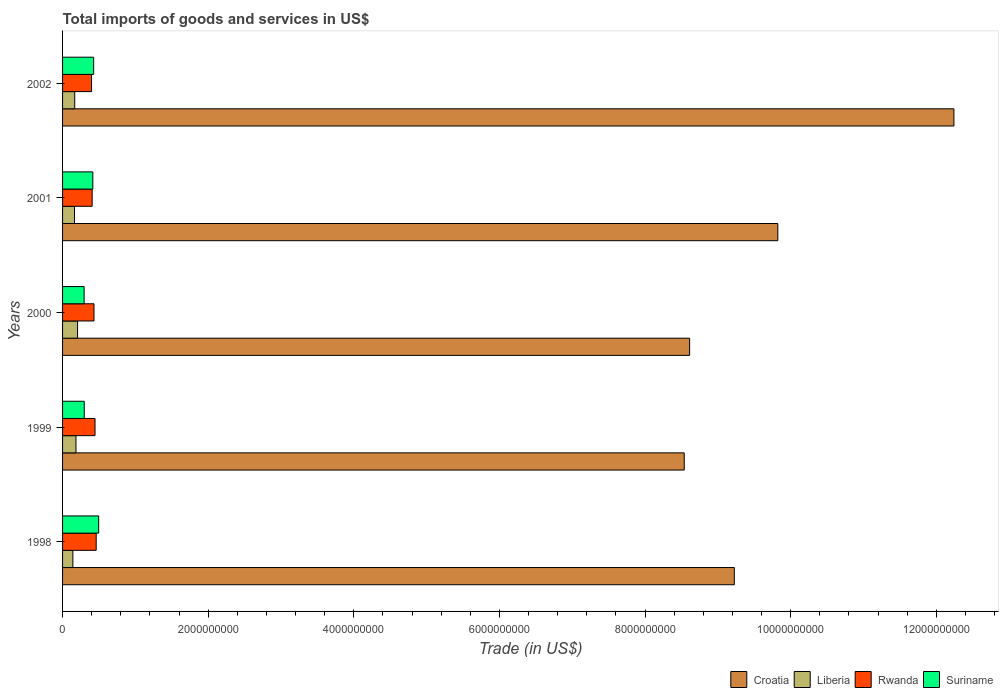How many different coloured bars are there?
Offer a very short reply. 4. How many groups of bars are there?
Keep it short and to the point. 5. Are the number of bars per tick equal to the number of legend labels?
Keep it short and to the point. Yes. How many bars are there on the 5th tick from the bottom?
Your response must be concise. 4. What is the total imports of goods and services in Croatia in 1998?
Ensure brevity in your answer.  9.23e+09. Across all years, what is the maximum total imports of goods and services in Liberia?
Make the answer very short. 2.06e+08. Across all years, what is the minimum total imports of goods and services in Rwanda?
Give a very brief answer. 3.98e+08. In which year was the total imports of goods and services in Suriname minimum?
Make the answer very short. 2000. What is the total total imports of goods and services in Rwanda in the graph?
Ensure brevity in your answer.  2.14e+09. What is the difference between the total imports of goods and services in Liberia in 1998 and that in 2001?
Make the answer very short. -2.22e+07. What is the difference between the total imports of goods and services in Liberia in 2001 and the total imports of goods and services in Rwanda in 2002?
Provide a succinct answer. -2.34e+08. What is the average total imports of goods and services in Rwanda per year?
Your answer should be very brief. 4.29e+08. In the year 1998, what is the difference between the total imports of goods and services in Rwanda and total imports of goods and services in Suriname?
Offer a terse response. -3.43e+07. In how many years, is the total imports of goods and services in Rwanda greater than 6000000000 US$?
Your answer should be very brief. 0. What is the ratio of the total imports of goods and services in Croatia in 1998 to that in 1999?
Give a very brief answer. 1.08. Is the total imports of goods and services in Liberia in 2000 less than that in 2002?
Offer a very short reply. No. Is the difference between the total imports of goods and services in Rwanda in 1998 and 1999 greater than the difference between the total imports of goods and services in Suriname in 1998 and 1999?
Offer a very short reply. No. What is the difference between the highest and the second highest total imports of goods and services in Rwanda?
Your response must be concise. 1.59e+07. What is the difference between the highest and the lowest total imports of goods and services in Liberia?
Offer a terse response. 6.45e+07. Is it the case that in every year, the sum of the total imports of goods and services in Croatia and total imports of goods and services in Suriname is greater than the sum of total imports of goods and services in Liberia and total imports of goods and services in Rwanda?
Make the answer very short. Yes. What does the 2nd bar from the top in 2001 represents?
Provide a short and direct response. Rwanda. What does the 1st bar from the bottom in 1998 represents?
Offer a very short reply. Croatia. What is the difference between two consecutive major ticks on the X-axis?
Provide a succinct answer. 2.00e+09. Does the graph contain any zero values?
Provide a succinct answer. No. Where does the legend appear in the graph?
Provide a succinct answer. Bottom right. What is the title of the graph?
Keep it short and to the point. Total imports of goods and services in US$. What is the label or title of the X-axis?
Offer a very short reply. Trade (in US$). What is the Trade (in US$) in Croatia in 1998?
Your answer should be compact. 9.23e+09. What is the Trade (in US$) of Liberia in 1998?
Offer a terse response. 1.42e+08. What is the Trade (in US$) of Rwanda in 1998?
Offer a very short reply. 4.62e+08. What is the Trade (in US$) of Suriname in 1998?
Your answer should be compact. 4.96e+08. What is the Trade (in US$) in Croatia in 1999?
Keep it short and to the point. 8.54e+09. What is the Trade (in US$) in Liberia in 1999?
Keep it short and to the point. 1.84e+08. What is the Trade (in US$) of Rwanda in 1999?
Ensure brevity in your answer.  4.46e+08. What is the Trade (in US$) in Suriname in 1999?
Keep it short and to the point. 2.98e+08. What is the Trade (in US$) in Croatia in 2000?
Make the answer very short. 8.61e+09. What is the Trade (in US$) in Liberia in 2000?
Offer a terse response. 2.06e+08. What is the Trade (in US$) of Rwanda in 2000?
Offer a terse response. 4.32e+08. What is the Trade (in US$) of Suriname in 2000?
Your answer should be very brief. 2.96e+08. What is the Trade (in US$) of Croatia in 2001?
Offer a very short reply. 9.82e+09. What is the Trade (in US$) in Liberia in 2001?
Provide a short and direct response. 1.64e+08. What is the Trade (in US$) of Rwanda in 2001?
Your answer should be very brief. 4.07e+08. What is the Trade (in US$) of Suriname in 2001?
Provide a short and direct response. 4.16e+08. What is the Trade (in US$) in Croatia in 2002?
Offer a terse response. 1.22e+1. What is the Trade (in US$) in Liberia in 2002?
Your answer should be compact. 1.67e+08. What is the Trade (in US$) in Rwanda in 2002?
Make the answer very short. 3.98e+08. What is the Trade (in US$) in Suriname in 2002?
Ensure brevity in your answer.  4.27e+08. Across all years, what is the maximum Trade (in US$) in Croatia?
Your response must be concise. 1.22e+1. Across all years, what is the maximum Trade (in US$) in Liberia?
Provide a short and direct response. 2.06e+08. Across all years, what is the maximum Trade (in US$) in Rwanda?
Make the answer very short. 4.62e+08. Across all years, what is the maximum Trade (in US$) of Suriname?
Your response must be concise. 4.96e+08. Across all years, what is the minimum Trade (in US$) of Croatia?
Your answer should be compact. 8.54e+09. Across all years, what is the minimum Trade (in US$) in Liberia?
Your answer should be very brief. 1.42e+08. Across all years, what is the minimum Trade (in US$) of Rwanda?
Your response must be concise. 3.98e+08. Across all years, what is the minimum Trade (in US$) of Suriname?
Offer a terse response. 2.96e+08. What is the total Trade (in US$) of Croatia in the graph?
Keep it short and to the point. 4.84e+1. What is the total Trade (in US$) in Liberia in the graph?
Provide a short and direct response. 8.62e+08. What is the total Trade (in US$) in Rwanda in the graph?
Ensure brevity in your answer.  2.14e+09. What is the total Trade (in US$) of Suriname in the graph?
Offer a very short reply. 1.93e+09. What is the difference between the Trade (in US$) of Croatia in 1998 and that in 1999?
Ensure brevity in your answer.  6.88e+08. What is the difference between the Trade (in US$) of Liberia in 1998 and that in 1999?
Provide a short and direct response. -4.26e+07. What is the difference between the Trade (in US$) of Rwanda in 1998 and that in 1999?
Offer a very short reply. 1.59e+07. What is the difference between the Trade (in US$) in Suriname in 1998 and that in 1999?
Your answer should be compact. 1.98e+08. What is the difference between the Trade (in US$) of Croatia in 1998 and that in 2000?
Your response must be concise. 6.14e+08. What is the difference between the Trade (in US$) in Liberia in 1998 and that in 2000?
Offer a very short reply. -6.45e+07. What is the difference between the Trade (in US$) in Rwanda in 1998 and that in 2000?
Keep it short and to the point. 3.01e+07. What is the difference between the Trade (in US$) in Suriname in 1998 and that in 2000?
Ensure brevity in your answer.  2.00e+08. What is the difference between the Trade (in US$) of Croatia in 1998 and that in 2001?
Ensure brevity in your answer.  -5.98e+08. What is the difference between the Trade (in US$) of Liberia in 1998 and that in 2001?
Your answer should be compact. -2.22e+07. What is the difference between the Trade (in US$) of Rwanda in 1998 and that in 2001?
Your response must be concise. 5.52e+07. What is the difference between the Trade (in US$) in Suriname in 1998 and that in 2001?
Ensure brevity in your answer.  8.05e+07. What is the difference between the Trade (in US$) of Croatia in 1998 and that in 2002?
Your response must be concise. -3.02e+09. What is the difference between the Trade (in US$) of Liberia in 1998 and that in 2002?
Provide a succinct answer. -2.56e+07. What is the difference between the Trade (in US$) in Rwanda in 1998 and that in 2002?
Your response must be concise. 6.39e+07. What is the difference between the Trade (in US$) of Suriname in 1998 and that in 2002?
Offer a terse response. 6.91e+07. What is the difference between the Trade (in US$) of Croatia in 1999 and that in 2000?
Ensure brevity in your answer.  -7.35e+07. What is the difference between the Trade (in US$) in Liberia in 1999 and that in 2000?
Provide a succinct answer. -2.19e+07. What is the difference between the Trade (in US$) in Rwanda in 1999 and that in 2000?
Your answer should be very brief. 1.42e+07. What is the difference between the Trade (in US$) of Suriname in 1999 and that in 2000?
Your response must be concise. 1.62e+06. What is the difference between the Trade (in US$) in Croatia in 1999 and that in 2001?
Offer a terse response. -1.29e+09. What is the difference between the Trade (in US$) in Liberia in 1999 and that in 2001?
Make the answer very short. 2.04e+07. What is the difference between the Trade (in US$) in Rwanda in 1999 and that in 2001?
Keep it short and to the point. 3.92e+07. What is the difference between the Trade (in US$) in Suriname in 1999 and that in 2001?
Make the answer very short. -1.18e+08. What is the difference between the Trade (in US$) in Croatia in 1999 and that in 2002?
Provide a succinct answer. -3.70e+09. What is the difference between the Trade (in US$) in Liberia in 1999 and that in 2002?
Provide a short and direct response. 1.70e+07. What is the difference between the Trade (in US$) of Rwanda in 1999 and that in 2002?
Offer a terse response. 4.80e+07. What is the difference between the Trade (in US$) in Suriname in 1999 and that in 2002?
Ensure brevity in your answer.  -1.29e+08. What is the difference between the Trade (in US$) in Croatia in 2000 and that in 2001?
Give a very brief answer. -1.21e+09. What is the difference between the Trade (in US$) in Liberia in 2000 and that in 2001?
Offer a terse response. 4.23e+07. What is the difference between the Trade (in US$) in Rwanda in 2000 and that in 2001?
Your response must be concise. 2.51e+07. What is the difference between the Trade (in US$) of Suriname in 2000 and that in 2001?
Give a very brief answer. -1.19e+08. What is the difference between the Trade (in US$) in Croatia in 2000 and that in 2002?
Provide a short and direct response. -3.63e+09. What is the difference between the Trade (in US$) of Liberia in 2000 and that in 2002?
Your answer should be very brief. 3.89e+07. What is the difference between the Trade (in US$) of Rwanda in 2000 and that in 2002?
Offer a terse response. 3.38e+07. What is the difference between the Trade (in US$) of Suriname in 2000 and that in 2002?
Your answer should be compact. -1.31e+08. What is the difference between the Trade (in US$) in Croatia in 2001 and that in 2002?
Give a very brief answer. -2.42e+09. What is the difference between the Trade (in US$) of Liberia in 2001 and that in 2002?
Keep it short and to the point. -3.44e+06. What is the difference between the Trade (in US$) of Rwanda in 2001 and that in 2002?
Make the answer very short. 8.75e+06. What is the difference between the Trade (in US$) in Suriname in 2001 and that in 2002?
Ensure brevity in your answer.  -1.14e+07. What is the difference between the Trade (in US$) in Croatia in 1998 and the Trade (in US$) in Liberia in 1999?
Keep it short and to the point. 9.04e+09. What is the difference between the Trade (in US$) in Croatia in 1998 and the Trade (in US$) in Rwanda in 1999?
Keep it short and to the point. 8.78e+09. What is the difference between the Trade (in US$) in Croatia in 1998 and the Trade (in US$) in Suriname in 1999?
Make the answer very short. 8.93e+09. What is the difference between the Trade (in US$) of Liberia in 1998 and the Trade (in US$) of Rwanda in 1999?
Give a very brief answer. -3.04e+08. What is the difference between the Trade (in US$) of Liberia in 1998 and the Trade (in US$) of Suriname in 1999?
Offer a very short reply. -1.56e+08. What is the difference between the Trade (in US$) of Rwanda in 1998 and the Trade (in US$) of Suriname in 1999?
Offer a very short reply. 1.64e+08. What is the difference between the Trade (in US$) in Croatia in 1998 and the Trade (in US$) in Liberia in 2000?
Your response must be concise. 9.02e+09. What is the difference between the Trade (in US$) of Croatia in 1998 and the Trade (in US$) of Rwanda in 2000?
Give a very brief answer. 8.79e+09. What is the difference between the Trade (in US$) of Croatia in 1998 and the Trade (in US$) of Suriname in 2000?
Provide a short and direct response. 8.93e+09. What is the difference between the Trade (in US$) in Liberia in 1998 and the Trade (in US$) in Rwanda in 2000?
Give a very brief answer. -2.90e+08. What is the difference between the Trade (in US$) of Liberia in 1998 and the Trade (in US$) of Suriname in 2000?
Your response must be concise. -1.55e+08. What is the difference between the Trade (in US$) of Rwanda in 1998 and the Trade (in US$) of Suriname in 2000?
Ensure brevity in your answer.  1.66e+08. What is the difference between the Trade (in US$) in Croatia in 1998 and the Trade (in US$) in Liberia in 2001?
Offer a terse response. 9.06e+09. What is the difference between the Trade (in US$) in Croatia in 1998 and the Trade (in US$) in Rwanda in 2001?
Make the answer very short. 8.82e+09. What is the difference between the Trade (in US$) in Croatia in 1998 and the Trade (in US$) in Suriname in 2001?
Provide a succinct answer. 8.81e+09. What is the difference between the Trade (in US$) of Liberia in 1998 and the Trade (in US$) of Rwanda in 2001?
Ensure brevity in your answer.  -2.65e+08. What is the difference between the Trade (in US$) in Liberia in 1998 and the Trade (in US$) in Suriname in 2001?
Ensure brevity in your answer.  -2.74e+08. What is the difference between the Trade (in US$) of Rwanda in 1998 and the Trade (in US$) of Suriname in 2001?
Offer a terse response. 4.62e+07. What is the difference between the Trade (in US$) in Croatia in 1998 and the Trade (in US$) in Liberia in 2002?
Ensure brevity in your answer.  9.06e+09. What is the difference between the Trade (in US$) in Croatia in 1998 and the Trade (in US$) in Rwanda in 2002?
Make the answer very short. 8.83e+09. What is the difference between the Trade (in US$) of Croatia in 1998 and the Trade (in US$) of Suriname in 2002?
Give a very brief answer. 8.80e+09. What is the difference between the Trade (in US$) in Liberia in 1998 and the Trade (in US$) in Rwanda in 2002?
Offer a very short reply. -2.56e+08. What is the difference between the Trade (in US$) of Liberia in 1998 and the Trade (in US$) of Suriname in 2002?
Your answer should be compact. -2.85e+08. What is the difference between the Trade (in US$) of Rwanda in 1998 and the Trade (in US$) of Suriname in 2002?
Give a very brief answer. 3.48e+07. What is the difference between the Trade (in US$) in Croatia in 1999 and the Trade (in US$) in Liberia in 2000?
Give a very brief answer. 8.33e+09. What is the difference between the Trade (in US$) of Croatia in 1999 and the Trade (in US$) of Rwanda in 2000?
Give a very brief answer. 8.11e+09. What is the difference between the Trade (in US$) in Croatia in 1999 and the Trade (in US$) in Suriname in 2000?
Give a very brief answer. 8.24e+09. What is the difference between the Trade (in US$) of Liberia in 1999 and the Trade (in US$) of Rwanda in 2000?
Offer a terse response. -2.48e+08. What is the difference between the Trade (in US$) of Liberia in 1999 and the Trade (in US$) of Suriname in 2000?
Keep it short and to the point. -1.12e+08. What is the difference between the Trade (in US$) of Rwanda in 1999 and the Trade (in US$) of Suriname in 2000?
Provide a short and direct response. 1.50e+08. What is the difference between the Trade (in US$) of Croatia in 1999 and the Trade (in US$) of Liberia in 2001?
Offer a terse response. 8.37e+09. What is the difference between the Trade (in US$) of Croatia in 1999 and the Trade (in US$) of Rwanda in 2001?
Offer a very short reply. 8.13e+09. What is the difference between the Trade (in US$) of Croatia in 1999 and the Trade (in US$) of Suriname in 2001?
Your answer should be compact. 8.12e+09. What is the difference between the Trade (in US$) of Liberia in 1999 and the Trade (in US$) of Rwanda in 2001?
Your answer should be very brief. -2.22e+08. What is the difference between the Trade (in US$) in Liberia in 1999 and the Trade (in US$) in Suriname in 2001?
Your answer should be very brief. -2.31e+08. What is the difference between the Trade (in US$) in Rwanda in 1999 and the Trade (in US$) in Suriname in 2001?
Provide a succinct answer. 3.03e+07. What is the difference between the Trade (in US$) in Croatia in 1999 and the Trade (in US$) in Liberia in 2002?
Ensure brevity in your answer.  8.37e+09. What is the difference between the Trade (in US$) in Croatia in 1999 and the Trade (in US$) in Rwanda in 2002?
Your response must be concise. 8.14e+09. What is the difference between the Trade (in US$) in Croatia in 1999 and the Trade (in US$) in Suriname in 2002?
Give a very brief answer. 8.11e+09. What is the difference between the Trade (in US$) of Liberia in 1999 and the Trade (in US$) of Rwanda in 2002?
Give a very brief answer. -2.14e+08. What is the difference between the Trade (in US$) in Liberia in 1999 and the Trade (in US$) in Suriname in 2002?
Your response must be concise. -2.43e+08. What is the difference between the Trade (in US$) in Rwanda in 1999 and the Trade (in US$) in Suriname in 2002?
Provide a succinct answer. 1.89e+07. What is the difference between the Trade (in US$) in Croatia in 2000 and the Trade (in US$) in Liberia in 2001?
Make the answer very short. 8.45e+09. What is the difference between the Trade (in US$) in Croatia in 2000 and the Trade (in US$) in Rwanda in 2001?
Your response must be concise. 8.21e+09. What is the difference between the Trade (in US$) of Croatia in 2000 and the Trade (in US$) of Suriname in 2001?
Your answer should be very brief. 8.20e+09. What is the difference between the Trade (in US$) of Liberia in 2000 and the Trade (in US$) of Rwanda in 2001?
Give a very brief answer. -2.01e+08. What is the difference between the Trade (in US$) in Liberia in 2000 and the Trade (in US$) in Suriname in 2001?
Your response must be concise. -2.10e+08. What is the difference between the Trade (in US$) in Rwanda in 2000 and the Trade (in US$) in Suriname in 2001?
Your answer should be very brief. 1.61e+07. What is the difference between the Trade (in US$) in Croatia in 2000 and the Trade (in US$) in Liberia in 2002?
Provide a succinct answer. 8.45e+09. What is the difference between the Trade (in US$) in Croatia in 2000 and the Trade (in US$) in Rwanda in 2002?
Offer a very short reply. 8.21e+09. What is the difference between the Trade (in US$) of Croatia in 2000 and the Trade (in US$) of Suriname in 2002?
Give a very brief answer. 8.19e+09. What is the difference between the Trade (in US$) of Liberia in 2000 and the Trade (in US$) of Rwanda in 2002?
Keep it short and to the point. -1.92e+08. What is the difference between the Trade (in US$) of Liberia in 2000 and the Trade (in US$) of Suriname in 2002?
Your response must be concise. -2.21e+08. What is the difference between the Trade (in US$) in Rwanda in 2000 and the Trade (in US$) in Suriname in 2002?
Make the answer very short. 4.70e+06. What is the difference between the Trade (in US$) in Croatia in 2001 and the Trade (in US$) in Liberia in 2002?
Your answer should be very brief. 9.66e+09. What is the difference between the Trade (in US$) in Croatia in 2001 and the Trade (in US$) in Rwanda in 2002?
Keep it short and to the point. 9.43e+09. What is the difference between the Trade (in US$) in Croatia in 2001 and the Trade (in US$) in Suriname in 2002?
Give a very brief answer. 9.40e+09. What is the difference between the Trade (in US$) of Liberia in 2001 and the Trade (in US$) of Rwanda in 2002?
Provide a short and direct response. -2.34e+08. What is the difference between the Trade (in US$) of Liberia in 2001 and the Trade (in US$) of Suriname in 2002?
Ensure brevity in your answer.  -2.63e+08. What is the difference between the Trade (in US$) in Rwanda in 2001 and the Trade (in US$) in Suriname in 2002?
Your response must be concise. -2.04e+07. What is the average Trade (in US$) in Croatia per year?
Provide a succinct answer. 9.69e+09. What is the average Trade (in US$) in Liberia per year?
Offer a terse response. 1.72e+08. What is the average Trade (in US$) of Rwanda per year?
Give a very brief answer. 4.29e+08. What is the average Trade (in US$) of Suriname per year?
Offer a very short reply. 3.86e+08. In the year 1998, what is the difference between the Trade (in US$) of Croatia and Trade (in US$) of Liberia?
Your answer should be compact. 9.08e+09. In the year 1998, what is the difference between the Trade (in US$) of Croatia and Trade (in US$) of Rwanda?
Keep it short and to the point. 8.76e+09. In the year 1998, what is the difference between the Trade (in US$) in Croatia and Trade (in US$) in Suriname?
Offer a very short reply. 8.73e+09. In the year 1998, what is the difference between the Trade (in US$) in Liberia and Trade (in US$) in Rwanda?
Provide a succinct answer. -3.20e+08. In the year 1998, what is the difference between the Trade (in US$) of Liberia and Trade (in US$) of Suriname?
Offer a very short reply. -3.54e+08. In the year 1998, what is the difference between the Trade (in US$) of Rwanda and Trade (in US$) of Suriname?
Offer a very short reply. -3.43e+07. In the year 1999, what is the difference between the Trade (in US$) of Croatia and Trade (in US$) of Liberia?
Your response must be concise. 8.35e+09. In the year 1999, what is the difference between the Trade (in US$) of Croatia and Trade (in US$) of Rwanda?
Offer a terse response. 8.09e+09. In the year 1999, what is the difference between the Trade (in US$) of Croatia and Trade (in US$) of Suriname?
Make the answer very short. 8.24e+09. In the year 1999, what is the difference between the Trade (in US$) of Liberia and Trade (in US$) of Rwanda?
Make the answer very short. -2.62e+08. In the year 1999, what is the difference between the Trade (in US$) in Liberia and Trade (in US$) in Suriname?
Offer a very short reply. -1.14e+08. In the year 1999, what is the difference between the Trade (in US$) of Rwanda and Trade (in US$) of Suriname?
Your response must be concise. 1.48e+08. In the year 2000, what is the difference between the Trade (in US$) of Croatia and Trade (in US$) of Liberia?
Provide a short and direct response. 8.41e+09. In the year 2000, what is the difference between the Trade (in US$) in Croatia and Trade (in US$) in Rwanda?
Provide a short and direct response. 8.18e+09. In the year 2000, what is the difference between the Trade (in US$) in Croatia and Trade (in US$) in Suriname?
Give a very brief answer. 8.32e+09. In the year 2000, what is the difference between the Trade (in US$) of Liberia and Trade (in US$) of Rwanda?
Give a very brief answer. -2.26e+08. In the year 2000, what is the difference between the Trade (in US$) of Liberia and Trade (in US$) of Suriname?
Your answer should be very brief. -9.02e+07. In the year 2000, what is the difference between the Trade (in US$) in Rwanda and Trade (in US$) in Suriname?
Provide a short and direct response. 1.35e+08. In the year 2001, what is the difference between the Trade (in US$) of Croatia and Trade (in US$) of Liberia?
Your response must be concise. 9.66e+09. In the year 2001, what is the difference between the Trade (in US$) in Croatia and Trade (in US$) in Rwanda?
Provide a short and direct response. 9.42e+09. In the year 2001, what is the difference between the Trade (in US$) in Croatia and Trade (in US$) in Suriname?
Give a very brief answer. 9.41e+09. In the year 2001, what is the difference between the Trade (in US$) of Liberia and Trade (in US$) of Rwanda?
Offer a terse response. -2.43e+08. In the year 2001, what is the difference between the Trade (in US$) in Liberia and Trade (in US$) in Suriname?
Ensure brevity in your answer.  -2.52e+08. In the year 2001, what is the difference between the Trade (in US$) of Rwanda and Trade (in US$) of Suriname?
Your answer should be compact. -8.98e+06. In the year 2002, what is the difference between the Trade (in US$) in Croatia and Trade (in US$) in Liberia?
Provide a succinct answer. 1.21e+1. In the year 2002, what is the difference between the Trade (in US$) of Croatia and Trade (in US$) of Rwanda?
Your response must be concise. 1.18e+1. In the year 2002, what is the difference between the Trade (in US$) of Croatia and Trade (in US$) of Suriname?
Give a very brief answer. 1.18e+1. In the year 2002, what is the difference between the Trade (in US$) of Liberia and Trade (in US$) of Rwanda?
Offer a very short reply. -2.31e+08. In the year 2002, what is the difference between the Trade (in US$) of Liberia and Trade (in US$) of Suriname?
Your answer should be compact. -2.60e+08. In the year 2002, what is the difference between the Trade (in US$) in Rwanda and Trade (in US$) in Suriname?
Offer a very short reply. -2.91e+07. What is the ratio of the Trade (in US$) in Croatia in 1998 to that in 1999?
Offer a terse response. 1.08. What is the ratio of the Trade (in US$) of Liberia in 1998 to that in 1999?
Offer a very short reply. 0.77. What is the ratio of the Trade (in US$) of Rwanda in 1998 to that in 1999?
Ensure brevity in your answer.  1.04. What is the ratio of the Trade (in US$) of Suriname in 1998 to that in 1999?
Offer a very short reply. 1.67. What is the ratio of the Trade (in US$) in Croatia in 1998 to that in 2000?
Your answer should be compact. 1.07. What is the ratio of the Trade (in US$) of Liberia in 1998 to that in 2000?
Provide a short and direct response. 0.69. What is the ratio of the Trade (in US$) of Rwanda in 1998 to that in 2000?
Make the answer very short. 1.07. What is the ratio of the Trade (in US$) of Suriname in 1998 to that in 2000?
Provide a succinct answer. 1.67. What is the ratio of the Trade (in US$) of Croatia in 1998 to that in 2001?
Offer a very short reply. 0.94. What is the ratio of the Trade (in US$) of Liberia in 1998 to that in 2001?
Your answer should be very brief. 0.86. What is the ratio of the Trade (in US$) of Rwanda in 1998 to that in 2001?
Your answer should be compact. 1.14. What is the ratio of the Trade (in US$) in Suriname in 1998 to that in 2001?
Provide a succinct answer. 1.19. What is the ratio of the Trade (in US$) in Croatia in 1998 to that in 2002?
Your answer should be compact. 0.75. What is the ratio of the Trade (in US$) in Liberia in 1998 to that in 2002?
Provide a succinct answer. 0.85. What is the ratio of the Trade (in US$) in Rwanda in 1998 to that in 2002?
Keep it short and to the point. 1.16. What is the ratio of the Trade (in US$) of Suriname in 1998 to that in 2002?
Keep it short and to the point. 1.16. What is the ratio of the Trade (in US$) in Liberia in 1999 to that in 2000?
Offer a very short reply. 0.89. What is the ratio of the Trade (in US$) in Rwanda in 1999 to that in 2000?
Your answer should be compact. 1.03. What is the ratio of the Trade (in US$) of Suriname in 1999 to that in 2000?
Provide a succinct answer. 1.01. What is the ratio of the Trade (in US$) in Croatia in 1999 to that in 2001?
Give a very brief answer. 0.87. What is the ratio of the Trade (in US$) in Liberia in 1999 to that in 2001?
Offer a very short reply. 1.12. What is the ratio of the Trade (in US$) of Rwanda in 1999 to that in 2001?
Provide a succinct answer. 1.1. What is the ratio of the Trade (in US$) of Suriname in 1999 to that in 2001?
Provide a short and direct response. 0.72. What is the ratio of the Trade (in US$) of Croatia in 1999 to that in 2002?
Provide a short and direct response. 0.7. What is the ratio of the Trade (in US$) in Liberia in 1999 to that in 2002?
Ensure brevity in your answer.  1.1. What is the ratio of the Trade (in US$) of Rwanda in 1999 to that in 2002?
Offer a terse response. 1.12. What is the ratio of the Trade (in US$) in Suriname in 1999 to that in 2002?
Your answer should be compact. 0.7. What is the ratio of the Trade (in US$) in Croatia in 2000 to that in 2001?
Offer a terse response. 0.88. What is the ratio of the Trade (in US$) in Liberia in 2000 to that in 2001?
Offer a terse response. 1.26. What is the ratio of the Trade (in US$) of Rwanda in 2000 to that in 2001?
Make the answer very short. 1.06. What is the ratio of the Trade (in US$) in Suriname in 2000 to that in 2001?
Ensure brevity in your answer.  0.71. What is the ratio of the Trade (in US$) in Croatia in 2000 to that in 2002?
Ensure brevity in your answer.  0.7. What is the ratio of the Trade (in US$) of Liberia in 2000 to that in 2002?
Your response must be concise. 1.23. What is the ratio of the Trade (in US$) of Rwanda in 2000 to that in 2002?
Provide a short and direct response. 1.08. What is the ratio of the Trade (in US$) of Suriname in 2000 to that in 2002?
Offer a terse response. 0.69. What is the ratio of the Trade (in US$) in Croatia in 2001 to that in 2002?
Provide a short and direct response. 0.8. What is the ratio of the Trade (in US$) in Liberia in 2001 to that in 2002?
Make the answer very short. 0.98. What is the ratio of the Trade (in US$) of Rwanda in 2001 to that in 2002?
Offer a terse response. 1.02. What is the ratio of the Trade (in US$) of Suriname in 2001 to that in 2002?
Your response must be concise. 0.97. What is the difference between the highest and the second highest Trade (in US$) of Croatia?
Offer a terse response. 2.42e+09. What is the difference between the highest and the second highest Trade (in US$) of Liberia?
Ensure brevity in your answer.  2.19e+07. What is the difference between the highest and the second highest Trade (in US$) of Rwanda?
Your answer should be compact. 1.59e+07. What is the difference between the highest and the second highest Trade (in US$) in Suriname?
Offer a very short reply. 6.91e+07. What is the difference between the highest and the lowest Trade (in US$) of Croatia?
Offer a terse response. 3.70e+09. What is the difference between the highest and the lowest Trade (in US$) in Liberia?
Give a very brief answer. 6.45e+07. What is the difference between the highest and the lowest Trade (in US$) in Rwanda?
Keep it short and to the point. 6.39e+07. What is the difference between the highest and the lowest Trade (in US$) in Suriname?
Give a very brief answer. 2.00e+08. 